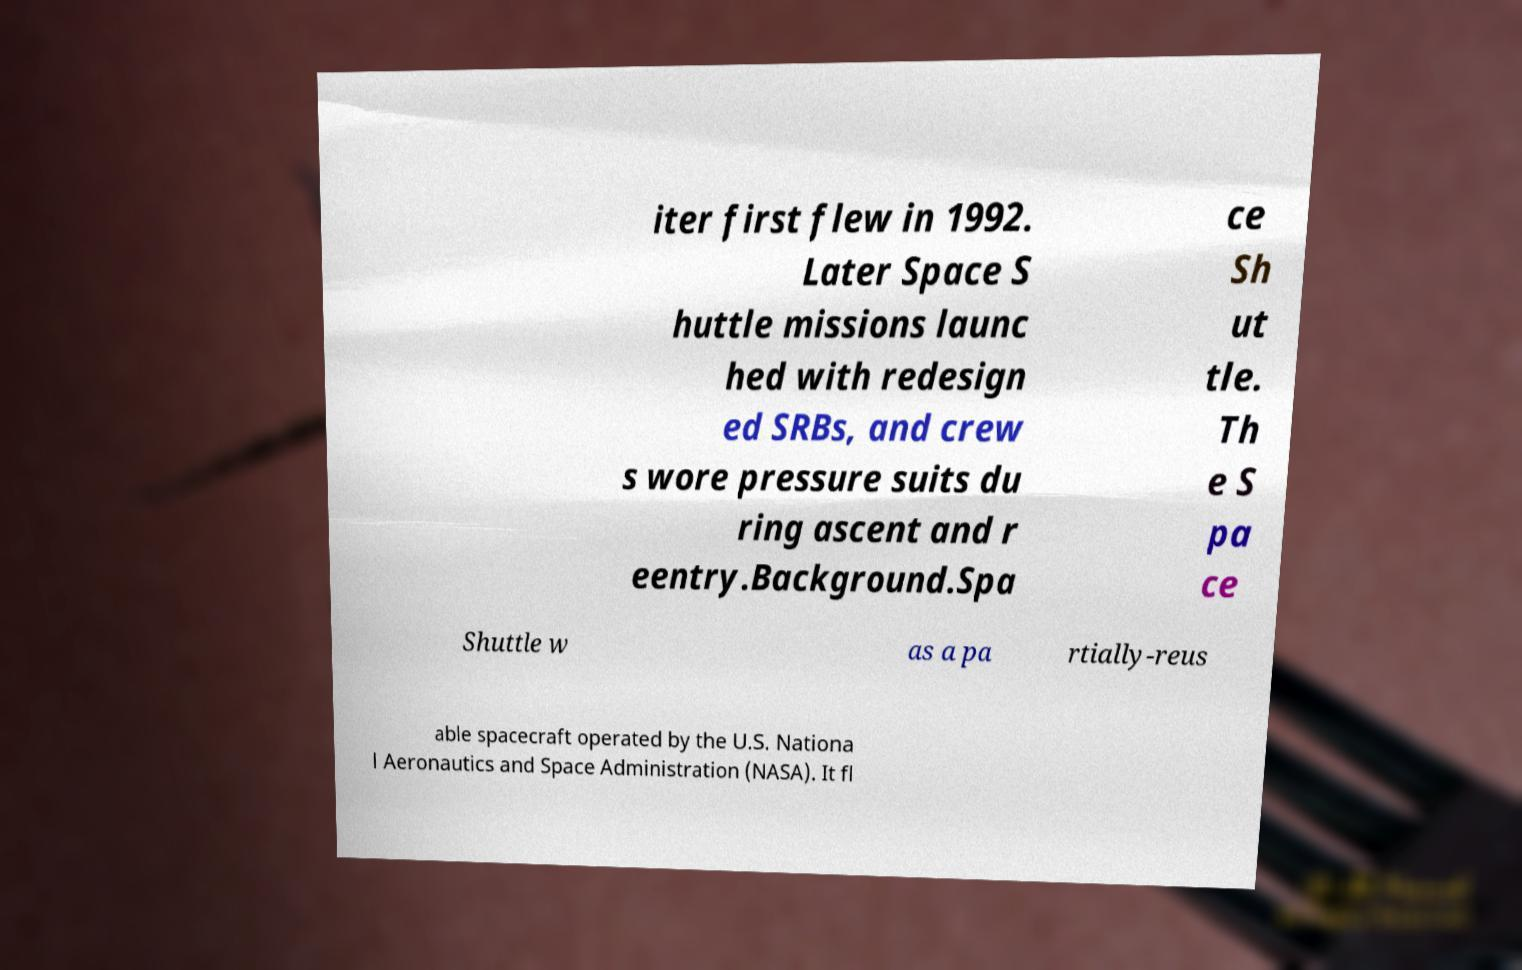Could you extract and type out the text from this image? iter first flew in 1992. Later Space S huttle missions launc hed with redesign ed SRBs, and crew s wore pressure suits du ring ascent and r eentry.Background.Spa ce Sh ut tle. Th e S pa ce Shuttle w as a pa rtially-reus able spacecraft operated by the U.S. Nationa l Aeronautics and Space Administration (NASA). It fl 